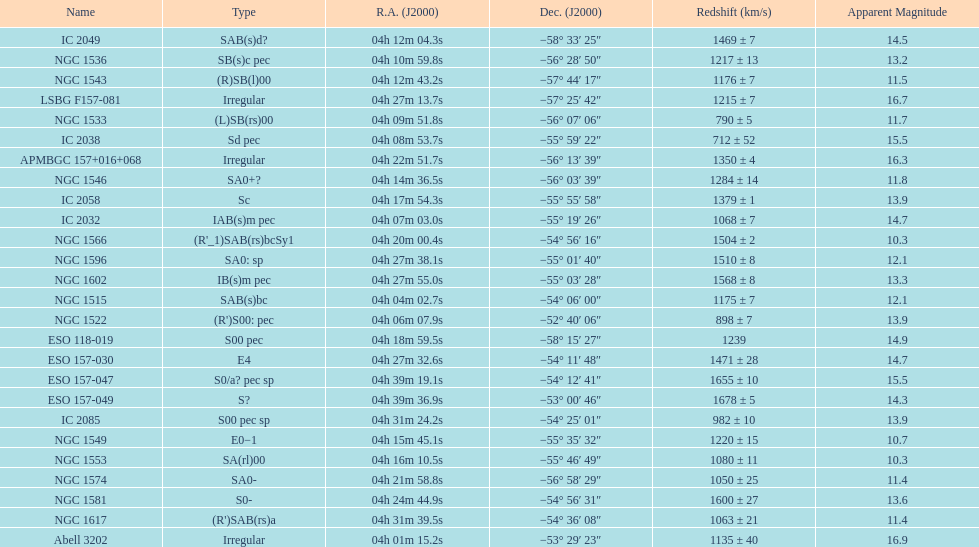Name the member with the highest apparent magnitude. Abell 3202. 